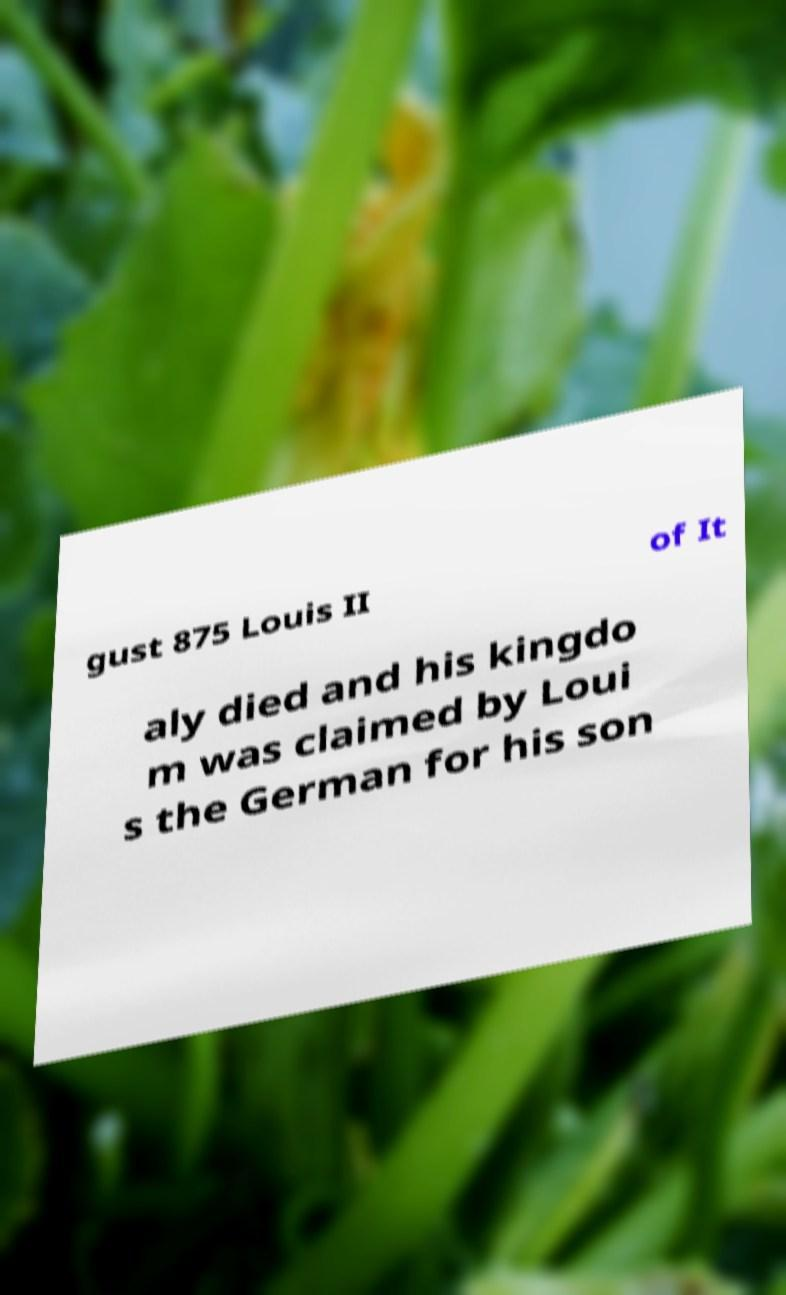Could you extract and type out the text from this image? gust 875 Louis II of It aly died and his kingdo m was claimed by Loui s the German for his son 